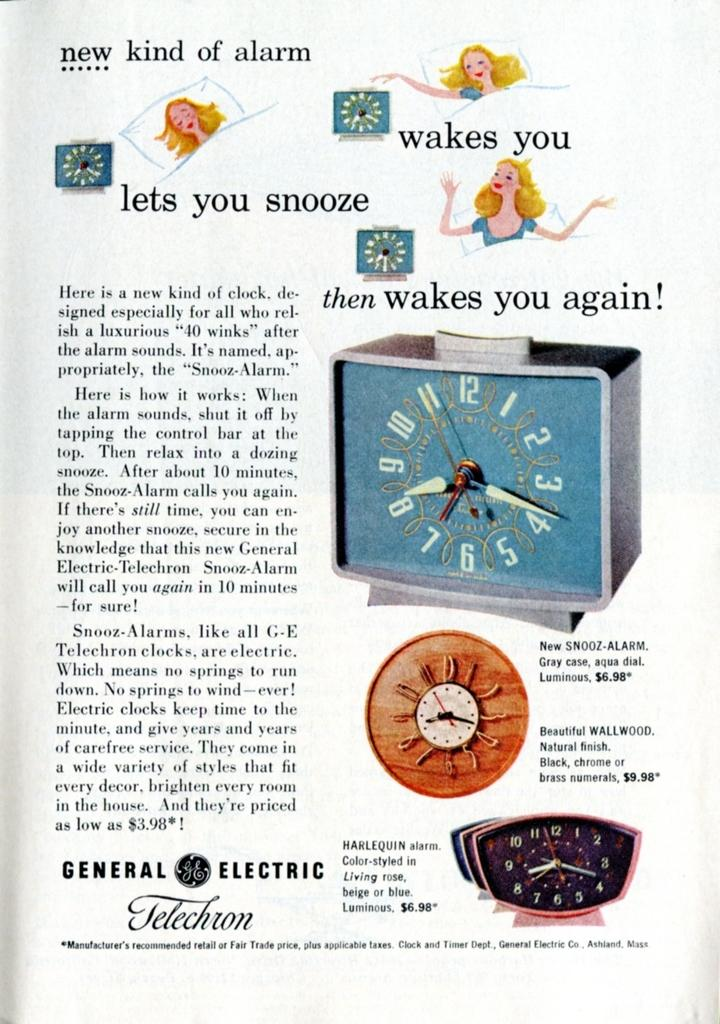<image>
Present a compact description of the photo's key features. an advert for a clock which says that it is a new kind of alarm. 